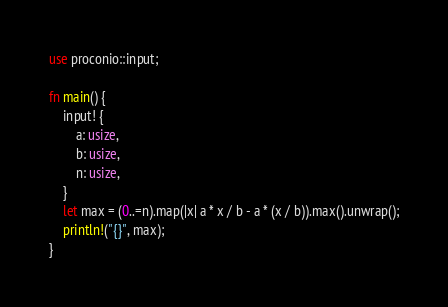<code> <loc_0><loc_0><loc_500><loc_500><_Rust_>use proconio::input;

fn main() {
    input! {
        a: usize,
        b: usize,
        n: usize,
    }
    let max = (0..=n).map(|x| a * x / b - a * (x / b)).max().unwrap();
    println!("{}", max);
}
</code> 